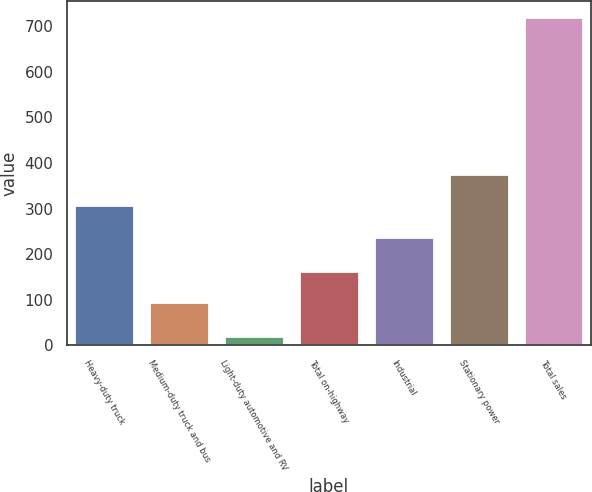Convert chart. <chart><loc_0><loc_0><loc_500><loc_500><bar_chart><fcel>Heavy-duty truck<fcel>Medium-duty truck and bus<fcel>Light-duty automotive and RV<fcel>Total on-highway<fcel>Industrial<fcel>Stationary power<fcel>Total sales<nl><fcel>306.9<fcel>94<fcel>21<fcel>163.9<fcel>237<fcel>376.8<fcel>720<nl></chart> 